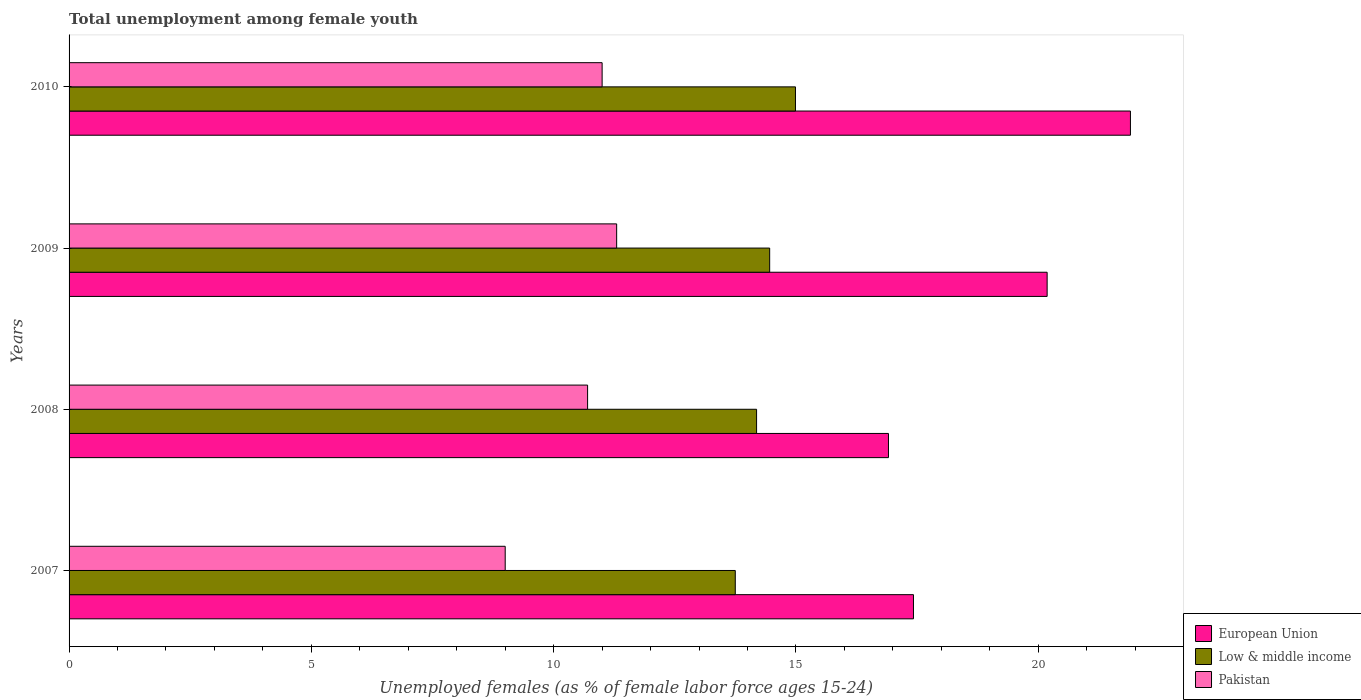How many different coloured bars are there?
Offer a terse response. 3. How many groups of bars are there?
Provide a succinct answer. 4. Are the number of bars per tick equal to the number of legend labels?
Keep it short and to the point. Yes. How many bars are there on the 3rd tick from the top?
Ensure brevity in your answer.  3. How many bars are there on the 2nd tick from the bottom?
Offer a very short reply. 3. What is the label of the 4th group of bars from the top?
Ensure brevity in your answer.  2007. What is the percentage of unemployed females in in Low & middle income in 2009?
Give a very brief answer. 14.46. Across all years, what is the maximum percentage of unemployed females in in Low & middle income?
Your answer should be very brief. 14.99. Across all years, what is the minimum percentage of unemployed females in in Pakistan?
Your answer should be very brief. 9. In which year was the percentage of unemployed females in in European Union maximum?
Provide a succinct answer. 2010. In which year was the percentage of unemployed females in in Pakistan minimum?
Keep it short and to the point. 2007. What is the total percentage of unemployed females in in Low & middle income in the graph?
Your response must be concise. 57.38. What is the difference between the percentage of unemployed females in in Low & middle income in 2007 and that in 2008?
Give a very brief answer. -0.44. What is the difference between the percentage of unemployed females in in Low & middle income in 2010 and the percentage of unemployed females in in European Union in 2009?
Make the answer very short. -5.19. In the year 2007, what is the difference between the percentage of unemployed females in in Pakistan and percentage of unemployed females in in Low & middle income?
Keep it short and to the point. -4.75. What is the ratio of the percentage of unemployed females in in European Union in 2008 to that in 2009?
Give a very brief answer. 0.84. Is the percentage of unemployed females in in Pakistan in 2007 less than that in 2008?
Offer a very short reply. Yes. Is the difference between the percentage of unemployed females in in Pakistan in 2007 and 2009 greater than the difference between the percentage of unemployed females in in Low & middle income in 2007 and 2009?
Give a very brief answer. No. What is the difference between the highest and the second highest percentage of unemployed females in in Low & middle income?
Provide a short and direct response. 0.53. What is the difference between the highest and the lowest percentage of unemployed females in in Pakistan?
Offer a terse response. 2.3. In how many years, is the percentage of unemployed females in in European Union greater than the average percentage of unemployed females in in European Union taken over all years?
Ensure brevity in your answer.  2. Is the sum of the percentage of unemployed females in in Low & middle income in 2007 and 2009 greater than the maximum percentage of unemployed females in in Pakistan across all years?
Provide a succinct answer. Yes. What does the 2nd bar from the bottom in 2009 represents?
Your answer should be compact. Low & middle income. Is it the case that in every year, the sum of the percentage of unemployed females in in European Union and percentage of unemployed females in in Pakistan is greater than the percentage of unemployed females in in Low & middle income?
Your answer should be compact. Yes. Are all the bars in the graph horizontal?
Give a very brief answer. Yes. How many years are there in the graph?
Offer a very short reply. 4. What is the difference between two consecutive major ticks on the X-axis?
Ensure brevity in your answer.  5. Does the graph contain any zero values?
Your answer should be compact. No. How are the legend labels stacked?
Offer a terse response. Vertical. What is the title of the graph?
Provide a succinct answer. Total unemployment among female youth. Does "Fiji" appear as one of the legend labels in the graph?
Ensure brevity in your answer.  No. What is the label or title of the X-axis?
Your answer should be very brief. Unemployed females (as % of female labor force ages 15-24). What is the Unemployed females (as % of female labor force ages 15-24) of European Union in 2007?
Make the answer very short. 17.42. What is the Unemployed females (as % of female labor force ages 15-24) of Low & middle income in 2007?
Your answer should be very brief. 13.75. What is the Unemployed females (as % of female labor force ages 15-24) of Pakistan in 2007?
Offer a terse response. 9. What is the Unemployed females (as % of female labor force ages 15-24) of European Union in 2008?
Offer a very short reply. 16.91. What is the Unemployed females (as % of female labor force ages 15-24) of Low & middle income in 2008?
Make the answer very short. 14.19. What is the Unemployed females (as % of female labor force ages 15-24) of Pakistan in 2008?
Your response must be concise. 10.7. What is the Unemployed females (as % of female labor force ages 15-24) of European Union in 2009?
Provide a succinct answer. 20.18. What is the Unemployed females (as % of female labor force ages 15-24) of Low & middle income in 2009?
Ensure brevity in your answer.  14.46. What is the Unemployed females (as % of female labor force ages 15-24) in Pakistan in 2009?
Keep it short and to the point. 11.3. What is the Unemployed females (as % of female labor force ages 15-24) in European Union in 2010?
Keep it short and to the point. 21.9. What is the Unemployed females (as % of female labor force ages 15-24) of Low & middle income in 2010?
Ensure brevity in your answer.  14.99. What is the Unemployed females (as % of female labor force ages 15-24) of Pakistan in 2010?
Offer a very short reply. 11. Across all years, what is the maximum Unemployed females (as % of female labor force ages 15-24) in European Union?
Make the answer very short. 21.9. Across all years, what is the maximum Unemployed females (as % of female labor force ages 15-24) in Low & middle income?
Keep it short and to the point. 14.99. Across all years, what is the maximum Unemployed females (as % of female labor force ages 15-24) of Pakistan?
Make the answer very short. 11.3. Across all years, what is the minimum Unemployed females (as % of female labor force ages 15-24) in European Union?
Offer a very short reply. 16.91. Across all years, what is the minimum Unemployed females (as % of female labor force ages 15-24) in Low & middle income?
Ensure brevity in your answer.  13.75. What is the total Unemployed females (as % of female labor force ages 15-24) of European Union in the graph?
Offer a terse response. 76.42. What is the total Unemployed females (as % of female labor force ages 15-24) in Low & middle income in the graph?
Your answer should be very brief. 57.38. What is the total Unemployed females (as % of female labor force ages 15-24) in Pakistan in the graph?
Your response must be concise. 42. What is the difference between the Unemployed females (as % of female labor force ages 15-24) of European Union in 2007 and that in 2008?
Provide a short and direct response. 0.52. What is the difference between the Unemployed females (as % of female labor force ages 15-24) in Low & middle income in 2007 and that in 2008?
Give a very brief answer. -0.44. What is the difference between the Unemployed females (as % of female labor force ages 15-24) of European Union in 2007 and that in 2009?
Give a very brief answer. -2.76. What is the difference between the Unemployed females (as % of female labor force ages 15-24) of Low & middle income in 2007 and that in 2009?
Provide a succinct answer. -0.71. What is the difference between the Unemployed females (as % of female labor force ages 15-24) in European Union in 2007 and that in 2010?
Your answer should be very brief. -4.48. What is the difference between the Unemployed females (as % of female labor force ages 15-24) of Low & middle income in 2007 and that in 2010?
Your answer should be very brief. -1.24. What is the difference between the Unemployed females (as % of female labor force ages 15-24) in Pakistan in 2007 and that in 2010?
Your response must be concise. -2. What is the difference between the Unemployed females (as % of female labor force ages 15-24) in European Union in 2008 and that in 2009?
Offer a terse response. -3.27. What is the difference between the Unemployed females (as % of female labor force ages 15-24) of Low & middle income in 2008 and that in 2009?
Your answer should be very brief. -0.27. What is the difference between the Unemployed females (as % of female labor force ages 15-24) in European Union in 2008 and that in 2010?
Your response must be concise. -4.99. What is the difference between the Unemployed females (as % of female labor force ages 15-24) in Low & middle income in 2008 and that in 2010?
Give a very brief answer. -0.8. What is the difference between the Unemployed females (as % of female labor force ages 15-24) of Pakistan in 2008 and that in 2010?
Offer a terse response. -0.3. What is the difference between the Unemployed females (as % of female labor force ages 15-24) of European Union in 2009 and that in 2010?
Provide a short and direct response. -1.72. What is the difference between the Unemployed females (as % of female labor force ages 15-24) of Low & middle income in 2009 and that in 2010?
Provide a short and direct response. -0.53. What is the difference between the Unemployed females (as % of female labor force ages 15-24) of European Union in 2007 and the Unemployed females (as % of female labor force ages 15-24) of Low & middle income in 2008?
Your response must be concise. 3.24. What is the difference between the Unemployed females (as % of female labor force ages 15-24) of European Union in 2007 and the Unemployed females (as % of female labor force ages 15-24) of Pakistan in 2008?
Provide a short and direct response. 6.72. What is the difference between the Unemployed females (as % of female labor force ages 15-24) of Low & middle income in 2007 and the Unemployed females (as % of female labor force ages 15-24) of Pakistan in 2008?
Give a very brief answer. 3.05. What is the difference between the Unemployed females (as % of female labor force ages 15-24) in European Union in 2007 and the Unemployed females (as % of female labor force ages 15-24) in Low & middle income in 2009?
Your answer should be very brief. 2.97. What is the difference between the Unemployed females (as % of female labor force ages 15-24) in European Union in 2007 and the Unemployed females (as % of female labor force ages 15-24) in Pakistan in 2009?
Ensure brevity in your answer.  6.12. What is the difference between the Unemployed females (as % of female labor force ages 15-24) in Low & middle income in 2007 and the Unemployed females (as % of female labor force ages 15-24) in Pakistan in 2009?
Your answer should be compact. 2.45. What is the difference between the Unemployed females (as % of female labor force ages 15-24) of European Union in 2007 and the Unemployed females (as % of female labor force ages 15-24) of Low & middle income in 2010?
Provide a short and direct response. 2.44. What is the difference between the Unemployed females (as % of female labor force ages 15-24) in European Union in 2007 and the Unemployed females (as % of female labor force ages 15-24) in Pakistan in 2010?
Provide a short and direct response. 6.42. What is the difference between the Unemployed females (as % of female labor force ages 15-24) in Low & middle income in 2007 and the Unemployed females (as % of female labor force ages 15-24) in Pakistan in 2010?
Provide a succinct answer. 2.75. What is the difference between the Unemployed females (as % of female labor force ages 15-24) of European Union in 2008 and the Unemployed females (as % of female labor force ages 15-24) of Low & middle income in 2009?
Offer a terse response. 2.45. What is the difference between the Unemployed females (as % of female labor force ages 15-24) of European Union in 2008 and the Unemployed females (as % of female labor force ages 15-24) of Pakistan in 2009?
Your response must be concise. 5.61. What is the difference between the Unemployed females (as % of female labor force ages 15-24) of Low & middle income in 2008 and the Unemployed females (as % of female labor force ages 15-24) of Pakistan in 2009?
Make the answer very short. 2.89. What is the difference between the Unemployed females (as % of female labor force ages 15-24) of European Union in 2008 and the Unemployed females (as % of female labor force ages 15-24) of Low & middle income in 2010?
Your answer should be compact. 1.92. What is the difference between the Unemployed females (as % of female labor force ages 15-24) in European Union in 2008 and the Unemployed females (as % of female labor force ages 15-24) in Pakistan in 2010?
Your response must be concise. 5.91. What is the difference between the Unemployed females (as % of female labor force ages 15-24) in Low & middle income in 2008 and the Unemployed females (as % of female labor force ages 15-24) in Pakistan in 2010?
Ensure brevity in your answer.  3.19. What is the difference between the Unemployed females (as % of female labor force ages 15-24) of European Union in 2009 and the Unemployed females (as % of female labor force ages 15-24) of Low & middle income in 2010?
Offer a terse response. 5.19. What is the difference between the Unemployed females (as % of female labor force ages 15-24) in European Union in 2009 and the Unemployed females (as % of female labor force ages 15-24) in Pakistan in 2010?
Your response must be concise. 9.18. What is the difference between the Unemployed females (as % of female labor force ages 15-24) in Low & middle income in 2009 and the Unemployed females (as % of female labor force ages 15-24) in Pakistan in 2010?
Your answer should be very brief. 3.46. What is the average Unemployed females (as % of female labor force ages 15-24) in European Union per year?
Provide a short and direct response. 19.1. What is the average Unemployed females (as % of female labor force ages 15-24) in Low & middle income per year?
Give a very brief answer. 14.35. In the year 2007, what is the difference between the Unemployed females (as % of female labor force ages 15-24) in European Union and Unemployed females (as % of female labor force ages 15-24) in Low & middle income?
Ensure brevity in your answer.  3.68. In the year 2007, what is the difference between the Unemployed females (as % of female labor force ages 15-24) in European Union and Unemployed females (as % of female labor force ages 15-24) in Pakistan?
Ensure brevity in your answer.  8.43. In the year 2007, what is the difference between the Unemployed females (as % of female labor force ages 15-24) of Low & middle income and Unemployed females (as % of female labor force ages 15-24) of Pakistan?
Provide a short and direct response. 4.75. In the year 2008, what is the difference between the Unemployed females (as % of female labor force ages 15-24) of European Union and Unemployed females (as % of female labor force ages 15-24) of Low & middle income?
Provide a succinct answer. 2.72. In the year 2008, what is the difference between the Unemployed females (as % of female labor force ages 15-24) of European Union and Unemployed females (as % of female labor force ages 15-24) of Pakistan?
Keep it short and to the point. 6.21. In the year 2008, what is the difference between the Unemployed females (as % of female labor force ages 15-24) of Low & middle income and Unemployed females (as % of female labor force ages 15-24) of Pakistan?
Provide a short and direct response. 3.49. In the year 2009, what is the difference between the Unemployed females (as % of female labor force ages 15-24) in European Union and Unemployed females (as % of female labor force ages 15-24) in Low & middle income?
Keep it short and to the point. 5.73. In the year 2009, what is the difference between the Unemployed females (as % of female labor force ages 15-24) of European Union and Unemployed females (as % of female labor force ages 15-24) of Pakistan?
Your answer should be very brief. 8.88. In the year 2009, what is the difference between the Unemployed females (as % of female labor force ages 15-24) in Low & middle income and Unemployed females (as % of female labor force ages 15-24) in Pakistan?
Give a very brief answer. 3.16. In the year 2010, what is the difference between the Unemployed females (as % of female labor force ages 15-24) in European Union and Unemployed females (as % of female labor force ages 15-24) in Low & middle income?
Offer a very short reply. 6.91. In the year 2010, what is the difference between the Unemployed females (as % of female labor force ages 15-24) of European Union and Unemployed females (as % of female labor force ages 15-24) of Pakistan?
Offer a very short reply. 10.9. In the year 2010, what is the difference between the Unemployed females (as % of female labor force ages 15-24) in Low & middle income and Unemployed females (as % of female labor force ages 15-24) in Pakistan?
Your answer should be compact. 3.99. What is the ratio of the Unemployed females (as % of female labor force ages 15-24) in European Union in 2007 to that in 2008?
Provide a short and direct response. 1.03. What is the ratio of the Unemployed females (as % of female labor force ages 15-24) of Pakistan in 2007 to that in 2008?
Provide a short and direct response. 0.84. What is the ratio of the Unemployed females (as % of female labor force ages 15-24) of European Union in 2007 to that in 2009?
Keep it short and to the point. 0.86. What is the ratio of the Unemployed females (as % of female labor force ages 15-24) in Low & middle income in 2007 to that in 2009?
Provide a short and direct response. 0.95. What is the ratio of the Unemployed females (as % of female labor force ages 15-24) of Pakistan in 2007 to that in 2009?
Make the answer very short. 0.8. What is the ratio of the Unemployed females (as % of female labor force ages 15-24) in European Union in 2007 to that in 2010?
Provide a succinct answer. 0.8. What is the ratio of the Unemployed females (as % of female labor force ages 15-24) in Low & middle income in 2007 to that in 2010?
Keep it short and to the point. 0.92. What is the ratio of the Unemployed females (as % of female labor force ages 15-24) in Pakistan in 2007 to that in 2010?
Offer a terse response. 0.82. What is the ratio of the Unemployed females (as % of female labor force ages 15-24) of European Union in 2008 to that in 2009?
Offer a terse response. 0.84. What is the ratio of the Unemployed females (as % of female labor force ages 15-24) in Low & middle income in 2008 to that in 2009?
Offer a very short reply. 0.98. What is the ratio of the Unemployed females (as % of female labor force ages 15-24) of Pakistan in 2008 to that in 2009?
Make the answer very short. 0.95. What is the ratio of the Unemployed females (as % of female labor force ages 15-24) in European Union in 2008 to that in 2010?
Your answer should be compact. 0.77. What is the ratio of the Unemployed females (as % of female labor force ages 15-24) of Low & middle income in 2008 to that in 2010?
Provide a short and direct response. 0.95. What is the ratio of the Unemployed females (as % of female labor force ages 15-24) of Pakistan in 2008 to that in 2010?
Give a very brief answer. 0.97. What is the ratio of the Unemployed females (as % of female labor force ages 15-24) of European Union in 2009 to that in 2010?
Offer a very short reply. 0.92. What is the ratio of the Unemployed females (as % of female labor force ages 15-24) of Low & middle income in 2009 to that in 2010?
Your answer should be compact. 0.96. What is the ratio of the Unemployed females (as % of female labor force ages 15-24) of Pakistan in 2009 to that in 2010?
Give a very brief answer. 1.03. What is the difference between the highest and the second highest Unemployed females (as % of female labor force ages 15-24) in European Union?
Provide a succinct answer. 1.72. What is the difference between the highest and the second highest Unemployed females (as % of female labor force ages 15-24) of Low & middle income?
Provide a succinct answer. 0.53. What is the difference between the highest and the second highest Unemployed females (as % of female labor force ages 15-24) in Pakistan?
Make the answer very short. 0.3. What is the difference between the highest and the lowest Unemployed females (as % of female labor force ages 15-24) in European Union?
Make the answer very short. 4.99. What is the difference between the highest and the lowest Unemployed females (as % of female labor force ages 15-24) of Low & middle income?
Keep it short and to the point. 1.24. What is the difference between the highest and the lowest Unemployed females (as % of female labor force ages 15-24) of Pakistan?
Your response must be concise. 2.3. 